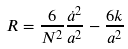Convert formula to latex. <formula><loc_0><loc_0><loc_500><loc_500>R = \frac { 6 } { N ^ { 2 } } \frac { \dot { a } ^ { 2 } } { a ^ { 2 } } - \frac { 6 k } { a ^ { 2 } }</formula> 